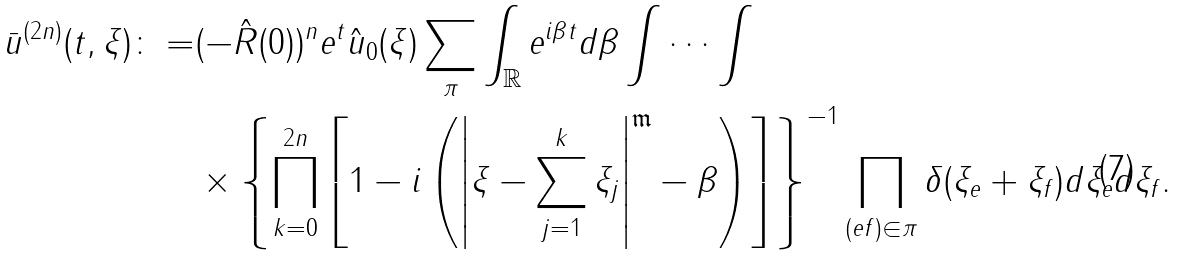Convert formula to latex. <formula><loc_0><loc_0><loc_500><loc_500>\bar { u } ^ { ( 2 n ) } ( t , \xi ) \colon = & ( - \hat { R } ( 0 ) ) ^ { n } e ^ { t } \hat { u } _ { 0 } ( \xi ) \sum _ { \pi } \int _ { \mathbb { R } } e ^ { i \beta t } d \beta \int \cdots \int \\ & \times \left \{ \prod _ { k = 0 } ^ { 2 n } \left [ 1 - i \left ( \left | \xi - \sum _ { j = 1 } ^ { k } \xi _ { j } \right | ^ { \mathfrak { m } } - \beta \right ) \right ] \right \} ^ { - 1 } \prod _ { ( e f ) \in \pi } \delta ( \xi _ { e } + \xi _ { f } ) d \xi _ { e } d \xi _ { f } .</formula> 